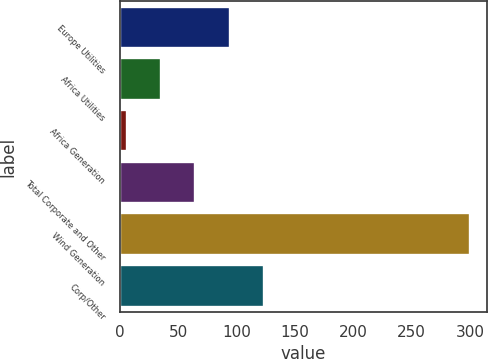Convert chart. <chart><loc_0><loc_0><loc_500><loc_500><bar_chart><fcel>Europe Utilities<fcel>Africa Utilities<fcel>Africa Generation<fcel>Total Corporate and Other<fcel>Wind Generation<fcel>Corp/Other<nl><fcel>94.2<fcel>35.4<fcel>6<fcel>64.8<fcel>300<fcel>123.6<nl></chart> 